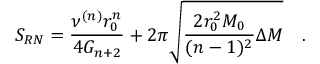Convert formula to latex. <formula><loc_0><loc_0><loc_500><loc_500>S _ { R N } = \frac { \nu ^ { ( n ) } r _ { 0 } ^ { n } } { 4 G _ { n + 2 } } + 2 \pi \sqrt { \frac { 2 r _ { 0 } ^ { 2 } M _ { 0 } } { ( n - 1 ) ^ { 2 } } \Delta M } \quad .</formula> 